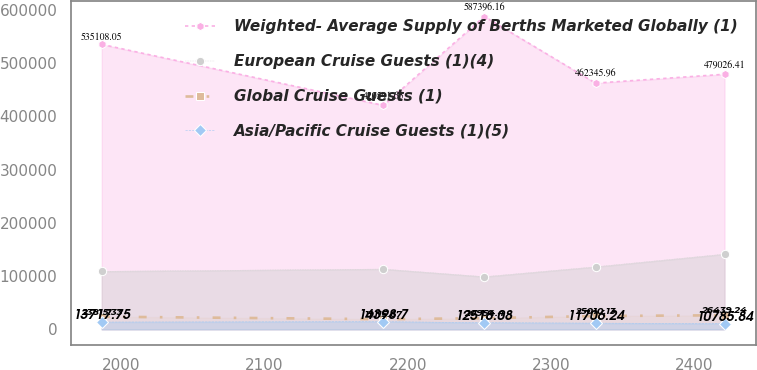Convert chart to OTSL. <chart><loc_0><loc_0><loc_500><loc_500><line_chart><ecel><fcel>Weighted- Average Supply of Berths Marketed Globally (1)<fcel>European Cruise Guests (1)(4)<fcel>Global Cruise Guests (1)<fcel>Asia/Pacific Cruise Guests (1)(5)<nl><fcel>1986.26<fcel>535108<fcel>108997<fcel>23815.3<fcel>13717.8<nl><fcel>2182.96<fcel>420592<fcel>113237<fcel>19115.7<fcel>14398.7<nl><fcel>2253.48<fcel>587396<fcel>98876.9<fcel>20954.4<fcel>12518.1<nl><fcel>2331.26<fcel>462346<fcel>117477<fcel>25010.1<fcel>11706.2<nl><fcel>2421.36<fcel>479026<fcel>141282<fcel>26439.2<fcel>10785.8<nl></chart> 